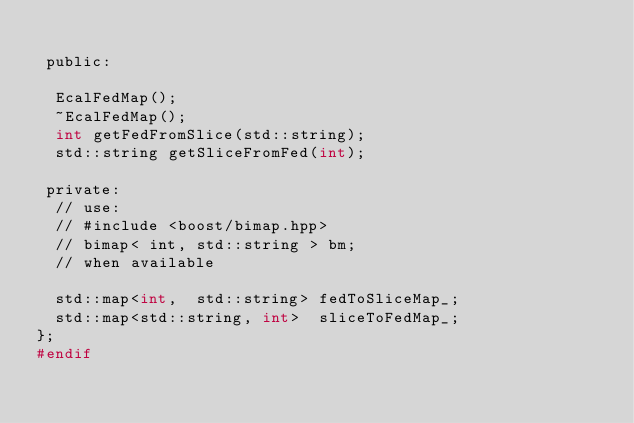Convert code to text. <code><loc_0><loc_0><loc_500><loc_500><_C_>
 public: 

  EcalFedMap();
  ~EcalFedMap();
  int getFedFromSlice(std::string);
  std::string getSliceFromFed(int);

 private:
  // use:
  // #include <boost/bimap.hpp>
  // bimap< int, std::string > bm; 
  // when available

  std::map<int,  std::string> fedToSliceMap_;
  std::map<std::string, int>  sliceToFedMap_;
};
#endif
</code> 